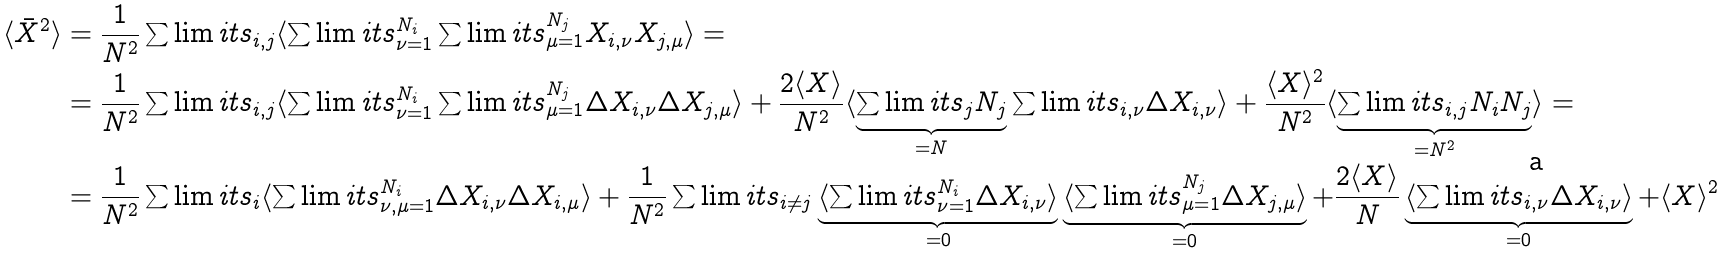<formula> <loc_0><loc_0><loc_500><loc_500>\langle \bar { X } ^ { 2 } \rangle & = \frac { 1 } { N ^ { 2 } } \sum \lim i t s _ { i , j } \langle \sum \lim i t s _ { \nu = 1 } ^ { N _ { i } } \sum \lim i t s _ { \mu = 1 } ^ { N _ { j } } X _ { i , \nu } X _ { j , \mu } \rangle = \\ & = \frac { 1 } { N ^ { 2 } } \sum \lim i t s _ { i , j } \langle \sum \lim i t s _ { \nu = 1 } ^ { N _ { i } } \sum \lim i t s _ { \mu = 1 } ^ { N _ { j } } \Delta X _ { i , \nu } \Delta X _ { j , \mu } \rangle + \frac { 2 \langle X \rangle } { N ^ { 2 } } \langle \underbrace { \sum \lim i t s _ { j } N _ { j } } _ { = N } \sum \lim i t s _ { i , \nu } \Delta X _ { i , \nu } \rangle + \frac { \langle X \rangle ^ { 2 } } { N ^ { 2 } } \langle \underbrace { \sum \lim i t s _ { i , j } N _ { i } N _ { j } } _ { = N ^ { 2 } } \rangle = \\ & = \frac { 1 } { N ^ { 2 } } \sum \lim i t s _ { i } \langle \sum \lim i t s _ { \nu , \mu = 1 } ^ { N _ { i } } \Delta X _ { i , \nu } \Delta X _ { i , \mu } \rangle + \frac { 1 } { N ^ { 2 } } \sum \lim i t s _ { i \neq j } \underbrace { \langle \sum \lim i t s _ { \nu = 1 } ^ { N _ { i } } \Delta X _ { i , \nu } \rangle } _ { = 0 } \underbrace { \langle \sum \lim i t s _ { \mu = 1 } ^ { N _ { j } } \Delta X _ { j , \mu } \rangle } _ { = 0 } + \frac { 2 \langle X \rangle } { N } \underbrace { \langle \sum \lim i t s _ { i , \nu } \Delta X _ { i , \nu } \rangle } _ { = 0 } + \langle X \rangle ^ { 2 }</formula> 